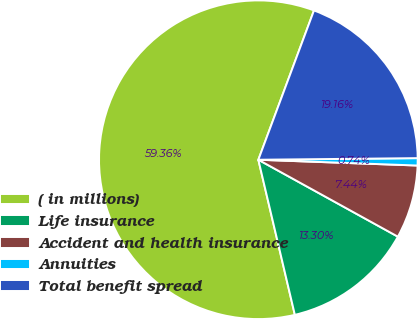<chart> <loc_0><loc_0><loc_500><loc_500><pie_chart><fcel>( in millions)<fcel>Life insurance<fcel>Accident and health insurance<fcel>Annuities<fcel>Total benefit spread<nl><fcel>59.35%<fcel>13.3%<fcel>7.44%<fcel>0.74%<fcel>19.16%<nl></chart> 